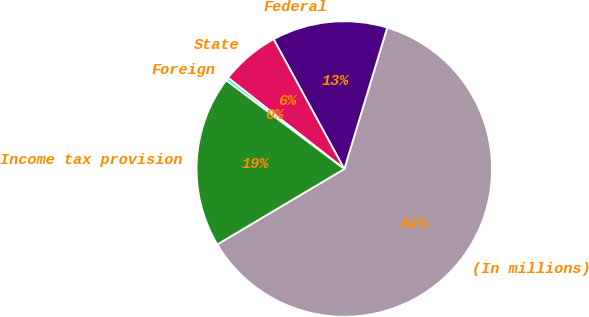<chart> <loc_0><loc_0><loc_500><loc_500><pie_chart><fcel>(In millions)<fcel>Federal<fcel>State<fcel>Foreign<fcel>Income tax provision<nl><fcel>61.78%<fcel>12.63%<fcel>6.48%<fcel>0.34%<fcel>18.77%<nl></chart> 